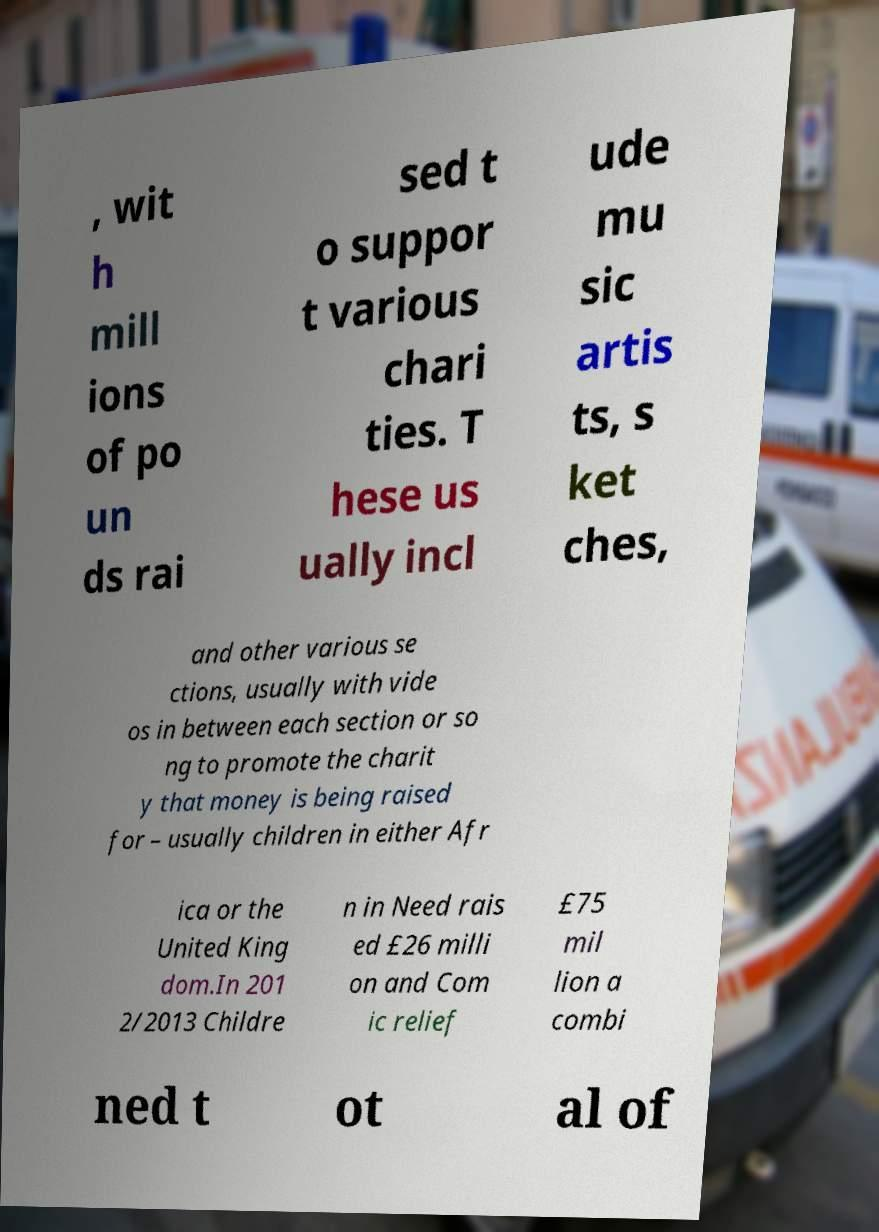Could you extract and type out the text from this image? , wit h mill ions of po un ds rai sed t o suppor t various chari ties. T hese us ually incl ude mu sic artis ts, s ket ches, and other various se ctions, usually with vide os in between each section or so ng to promote the charit y that money is being raised for – usually children in either Afr ica or the United King dom.In 201 2/2013 Childre n in Need rais ed £26 milli on and Com ic relief £75 mil lion a combi ned t ot al of 